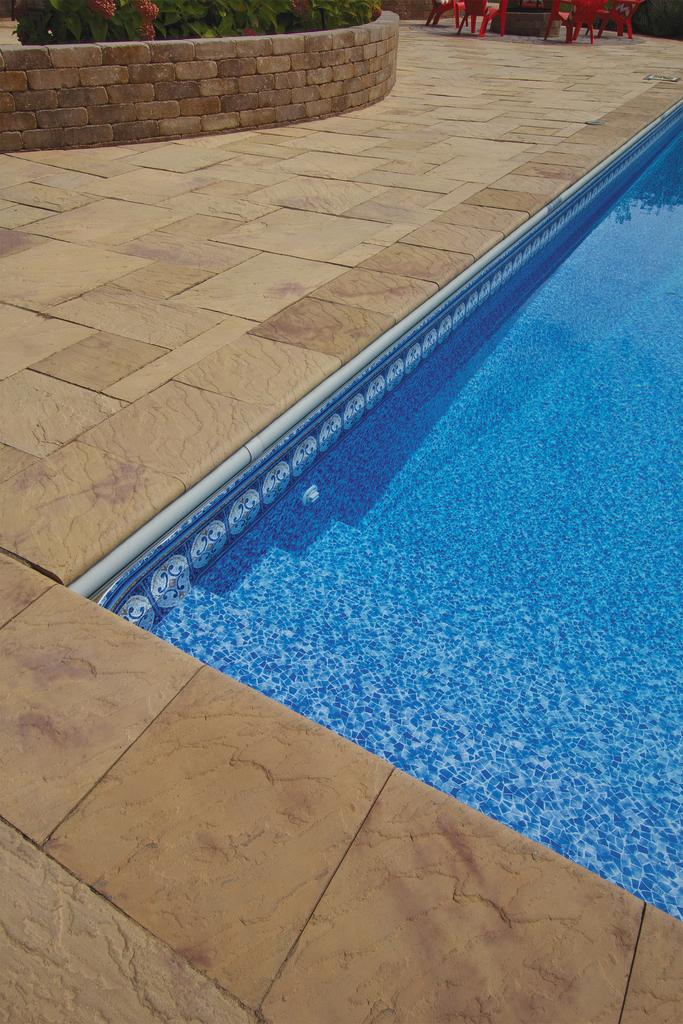What is the main feature in the center of the image? There is a swimming pool in the center of the image. What is located near the swimming pool? There is a platform near the swimming pool. What can be seen in the background of the image? There is a wall, plants with flowers, and chairs in the background of the image. What verse is being recited by the flowers in the image? There are no verses or recitations in the image; it features a swimming pool, platform, wall, plants with flowers. 